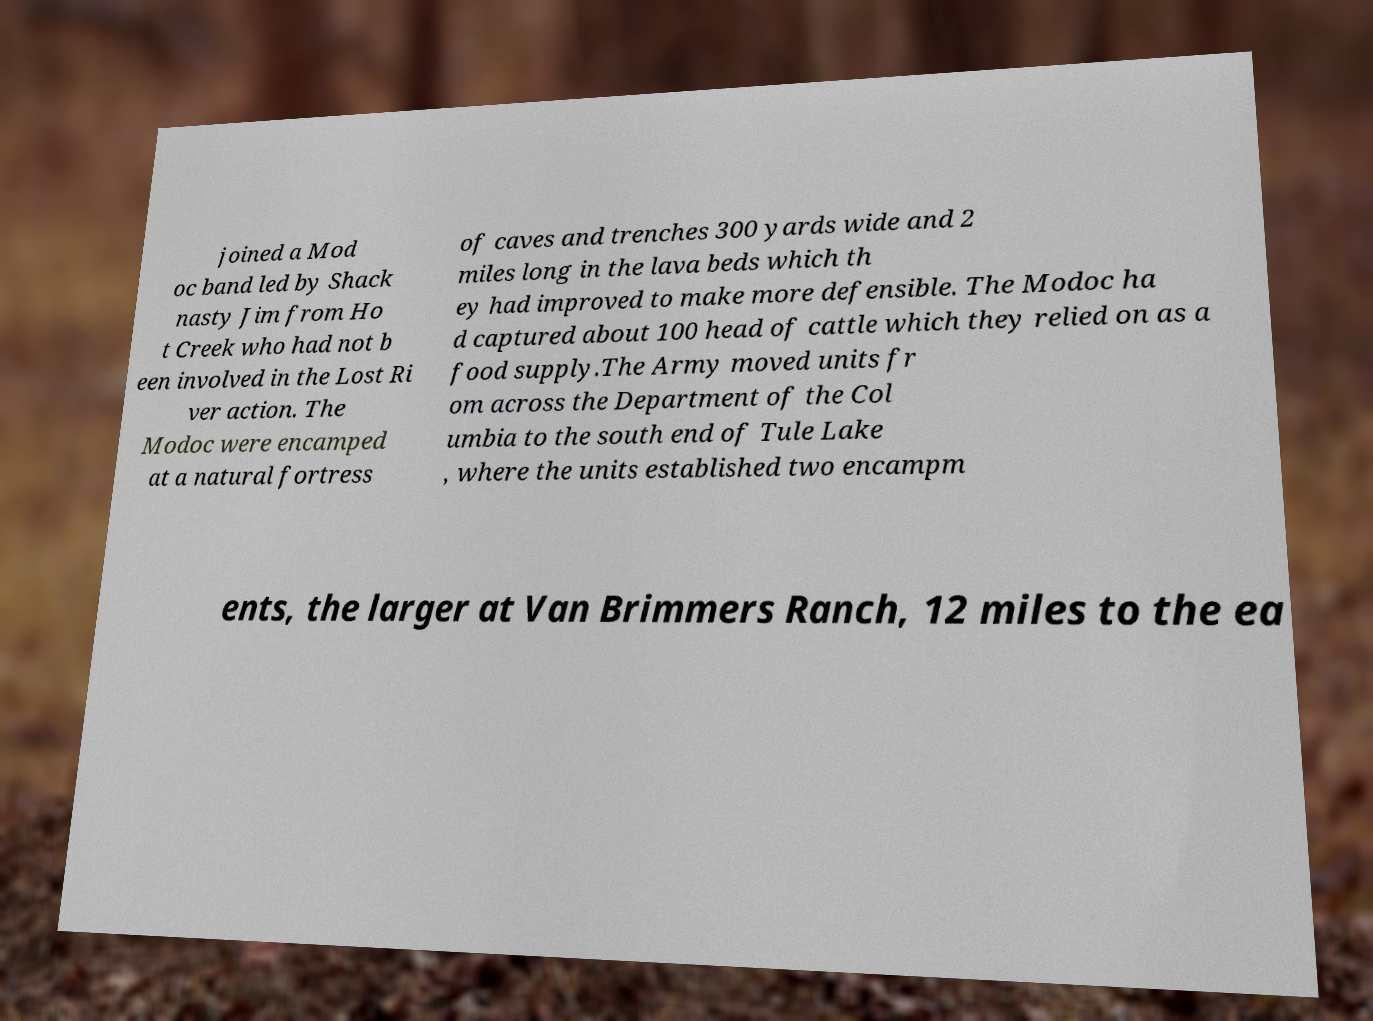Could you extract and type out the text from this image? joined a Mod oc band led by Shack nasty Jim from Ho t Creek who had not b een involved in the Lost Ri ver action. The Modoc were encamped at a natural fortress of caves and trenches 300 yards wide and 2 miles long in the lava beds which th ey had improved to make more defensible. The Modoc ha d captured about 100 head of cattle which they relied on as a food supply.The Army moved units fr om across the Department of the Col umbia to the south end of Tule Lake , where the units established two encampm ents, the larger at Van Brimmers Ranch, 12 miles to the ea 